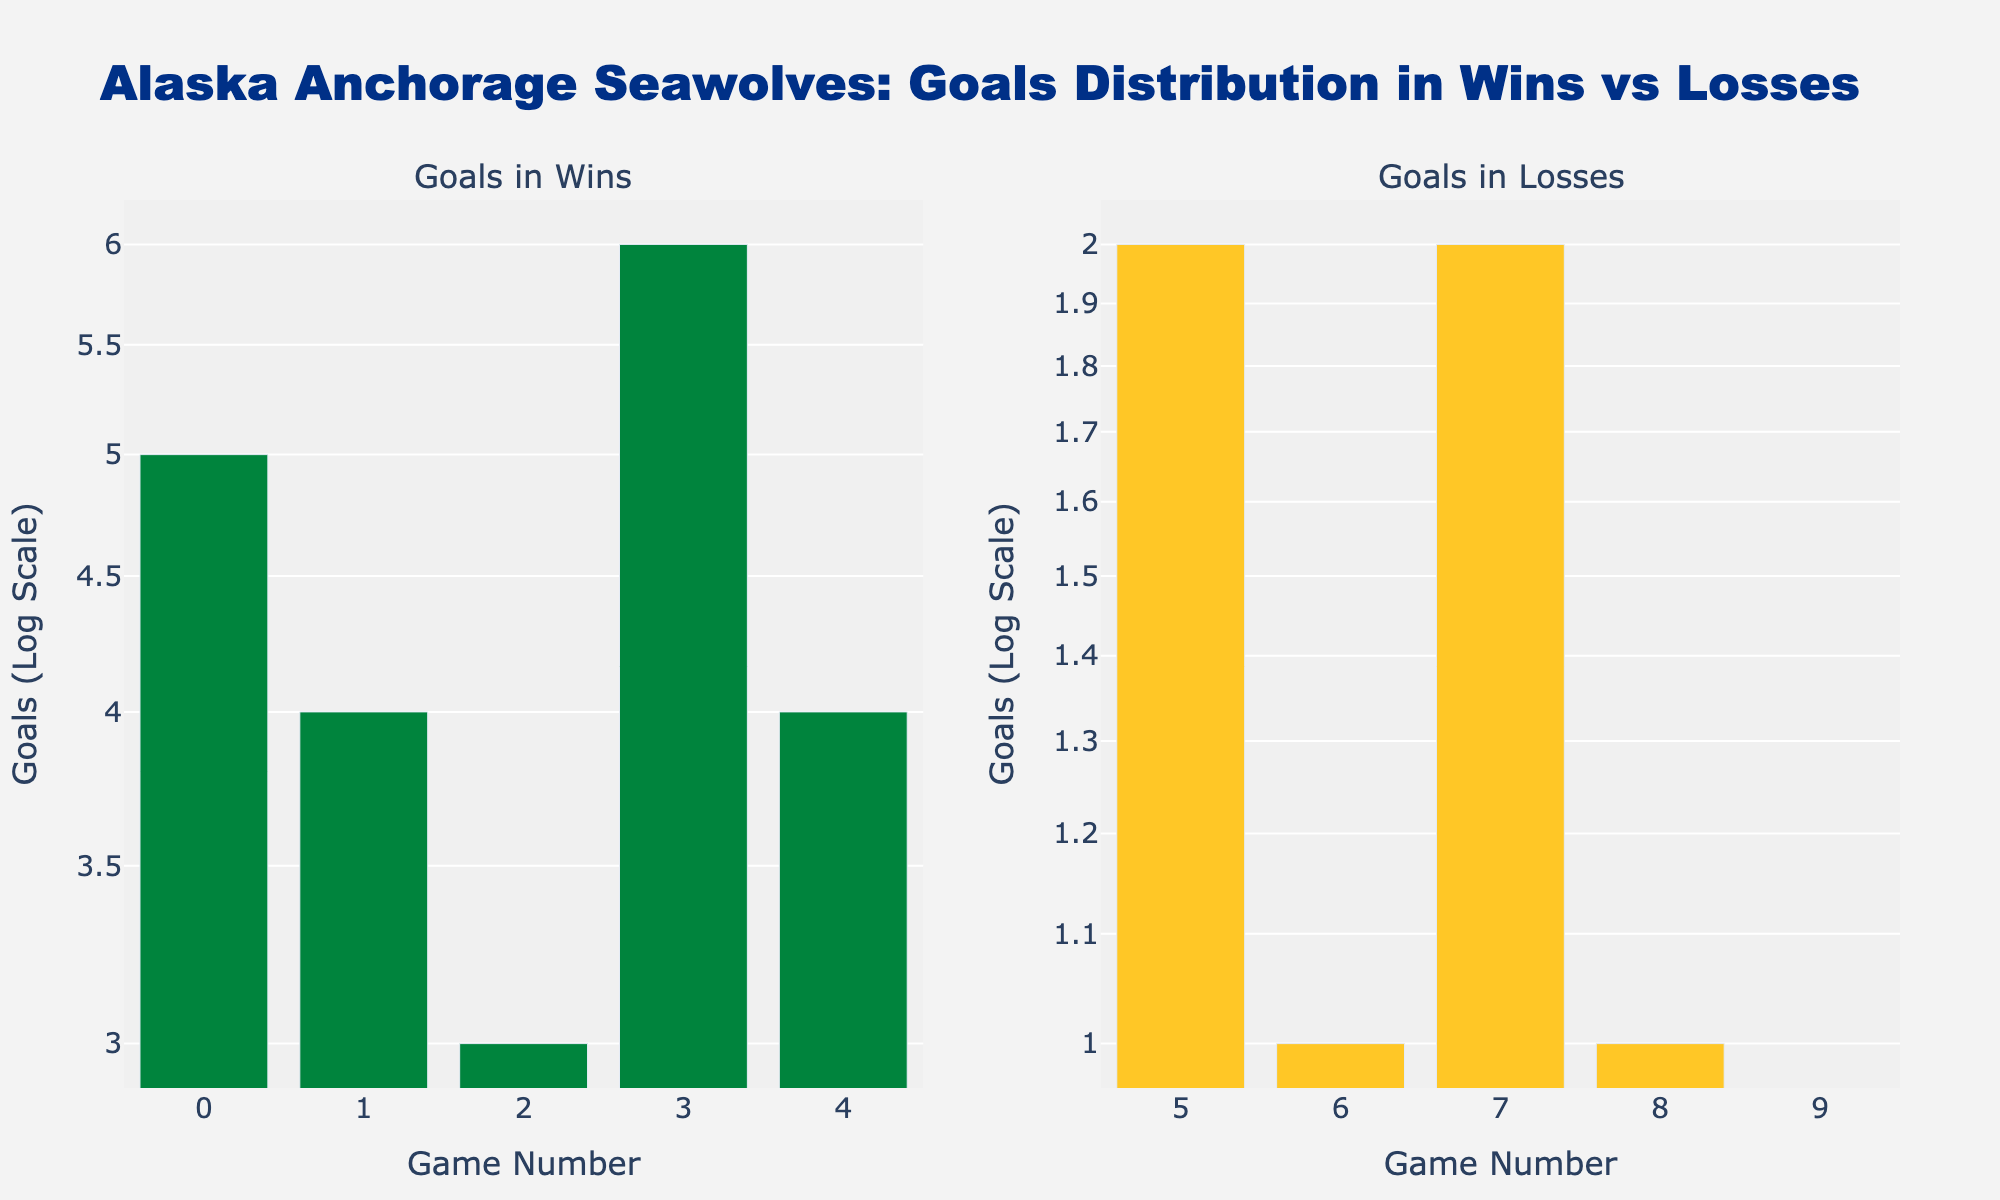What's the title of the figure? The title is prominently displayed at the top of the figure in large, bold text.
Answer: Alaska Anchorage Seawolves: Goals Distribution in Wins vs Losses How many wins are shown in the figure? Each bar in the 'Goals in Wins' subplot corresponds to one win. Counting the bars shows the total number of wins.
Answer: 5 How many goals did the Seawolves score in their highest-scoring loss? Inspect the bar heights in the 'Goals in Losses' subplot; the highest bar represents the most goals scored in a loss.
Answer: 2 What is the goal range (maximum to minimum) in wins? The range is determined by finding the highest and lowest goals scored in wins and subtracting the minimum from the maximum. The tallest bar in 'Goals in Wins' is 6 and the shortest is 3.
Answer: 3 (from 3 to 6) On a log scale, how is the difference between 1 and 2 goals visually represented compared to 4 and 5 goals? On a log scale, equal multiplicative differences (e.g., a factor of 2) get the same visual spacing, meaning 1 to 2 looks the same as 4 to 8. We compare each interval's visual spacing.
Answer: Smaller difference visually between 1 and 2 compared to 4 and 5 What is the most frequent number of goals scored in losses? Look at the 'Goals in Losses' subplot and identify the number of data points that share the same height.
Answer: 1 What's the average number of goals scored in wins? Sum the goals from wins (5 + 4 + 3 + 6 + 4) = 22. Then divide by the number of wins, which is 5.
Answer: 4.4 How do the number of wins and losses compare in the figure? Count the total number of data points (bars) for each outcome. The 'Wins' subplot has five bars, and the 'Losses' subplot has the same count.
Answer: Equal (5 each) Which bar color represents the wins, and which color represents the losses? The figure uses different colors for wins (green) and losses (yellow) as indicated in the traces.
Answer: Wins: Green, Losses: Yellow Does the figure use any images or logos as a watermark? The central part of the figure contains a faint image, which is the Seawolves logo.
Answer: Yes, Seawolves logo 